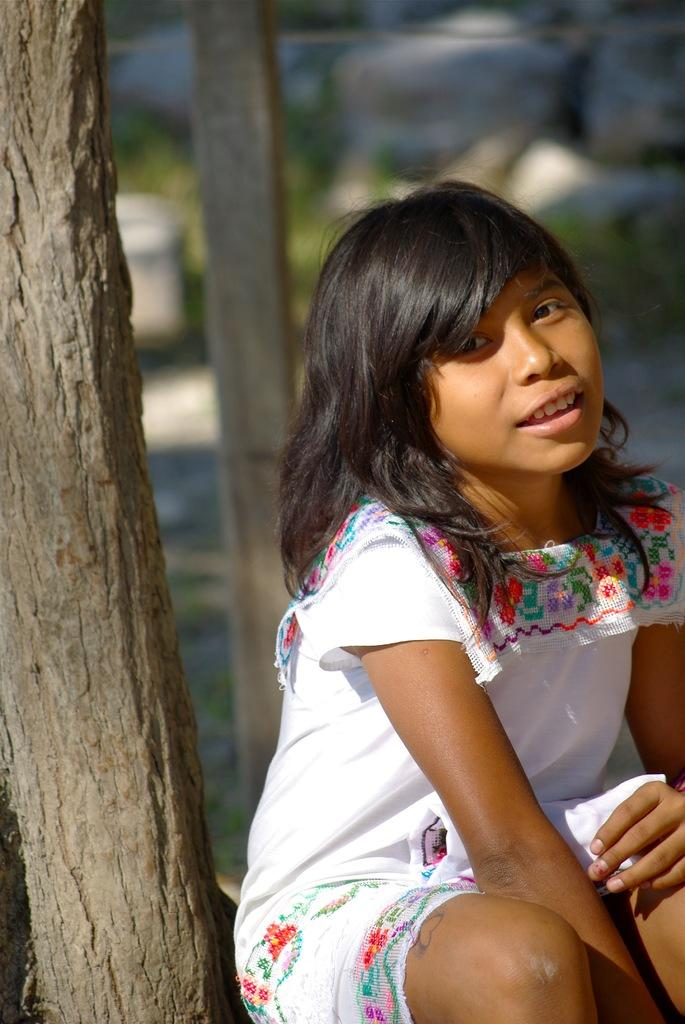What is the main subject of the image? There is a lady sitting in the image. What can be seen in the background of the image? The background of the image is blurred. Are there any other objects or structures in the image? Yes, there is a tree and a pole in the image. Can you hear the lady's throat cry out in the image? There is no sound or indication of a cry in the image, as it is a still photograph. 